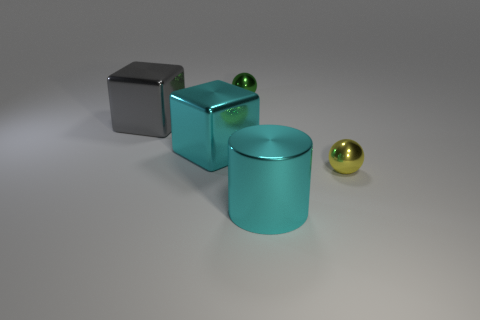Add 3 big purple objects. How many objects exist? 8 Subtract all cylinders. How many objects are left? 4 Subtract 0 blue cylinders. How many objects are left? 5 Subtract 1 spheres. How many spheres are left? 1 Subtract all cyan cubes. Subtract all purple balls. How many cubes are left? 1 Subtract all red cylinders. How many red cubes are left? 0 Subtract all small brown shiny cubes. Subtract all cyan cubes. How many objects are left? 4 Add 1 small green things. How many small green things are left? 2 Add 4 big metallic cylinders. How many big metallic cylinders exist? 5 